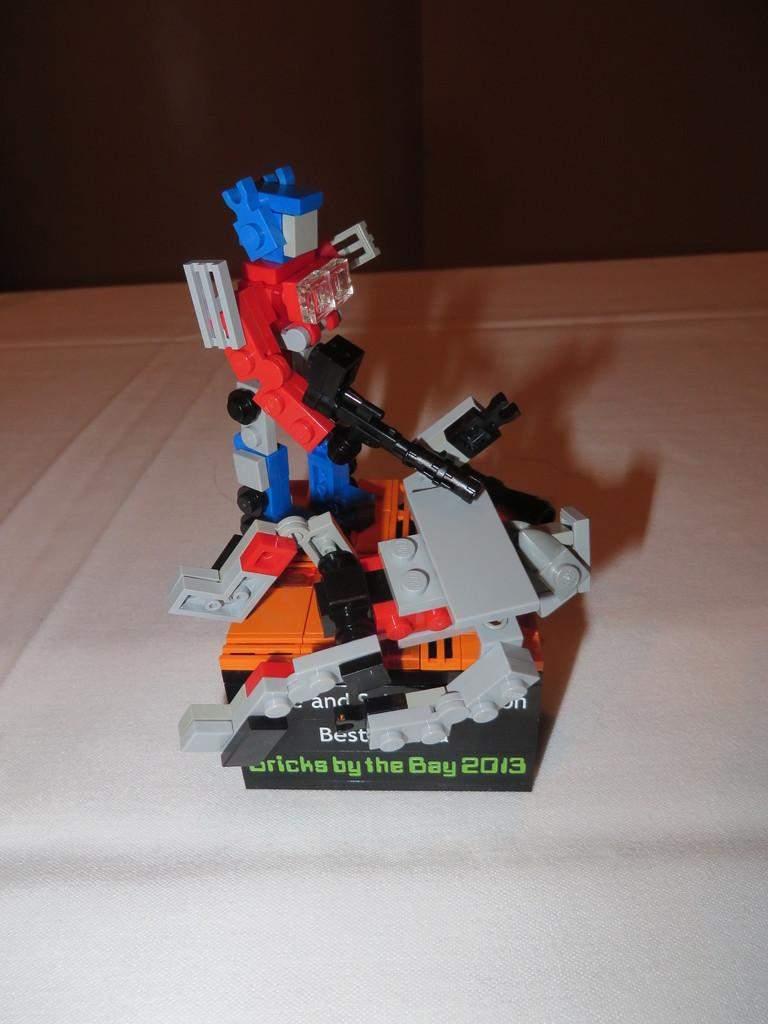What object is present in the image that resembles a toy? There is a toy in the image. Where is the toy located in the image? The toy is placed on a table. What can be observed about the background of the image? The background of the image is dark. What type of queen is present in the image? There is no queen present in the image; it features a toy placed on a table. What type of pies can be seen being served in the image? There are no pies present in the image. 